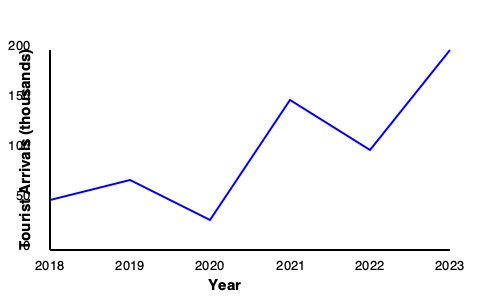Based on the line graph showing tourist arrivals in Vieques from 2018 to 2023, in which year did the island experience the most significant increase in visitors compared to the previous year? To determine the year with the most significant increase in visitors compared to the previous year, we need to analyze the changes between consecutive years:

1. 2018 to 2019: Slight decrease
2. 2019 to 2020: Moderate increase
3. 2020 to 2021: Large increase (steepest upward slope)
4. 2021 to 2022: Moderate increase
5. 2022 to 2023: Large increase, but not as steep as 2020 to 2021

The steepest upward slope indicates the largest increase in tourist arrivals. This occurs between 2020 and 2021, showing a jump from about 30,000 to 150,000 visitors.

This significant increase could be attributed to the easing of COVID-19 restrictions and pent-up travel demand following the pandemic's initial impact in 2020.
Answer: 2021 